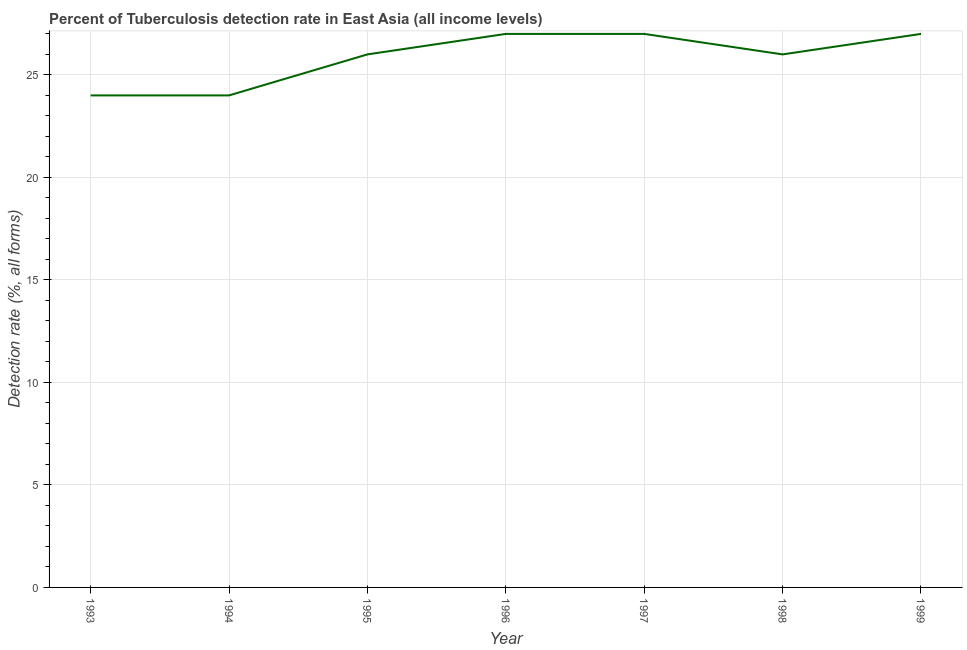What is the detection rate of tuberculosis in 1999?
Give a very brief answer. 27. Across all years, what is the maximum detection rate of tuberculosis?
Your answer should be very brief. 27. Across all years, what is the minimum detection rate of tuberculosis?
Your answer should be compact. 24. In which year was the detection rate of tuberculosis minimum?
Keep it short and to the point. 1993. What is the sum of the detection rate of tuberculosis?
Keep it short and to the point. 181. What is the difference between the detection rate of tuberculosis in 1998 and 1999?
Make the answer very short. -1. What is the average detection rate of tuberculosis per year?
Make the answer very short. 25.86. What is the median detection rate of tuberculosis?
Keep it short and to the point. 26. Do a majority of the years between 1999 and 1997 (inclusive) have detection rate of tuberculosis greater than 2 %?
Offer a very short reply. No. What is the ratio of the detection rate of tuberculosis in 1993 to that in 1997?
Your answer should be compact. 0.89. Is the difference between the detection rate of tuberculosis in 1993 and 1996 greater than the difference between any two years?
Provide a succinct answer. Yes. What is the difference between the highest and the second highest detection rate of tuberculosis?
Your response must be concise. 0. What is the difference between the highest and the lowest detection rate of tuberculosis?
Your response must be concise. 3. In how many years, is the detection rate of tuberculosis greater than the average detection rate of tuberculosis taken over all years?
Provide a short and direct response. 5. Does the detection rate of tuberculosis monotonically increase over the years?
Ensure brevity in your answer.  No. Are the values on the major ticks of Y-axis written in scientific E-notation?
Provide a short and direct response. No. Does the graph contain grids?
Make the answer very short. Yes. What is the title of the graph?
Ensure brevity in your answer.  Percent of Tuberculosis detection rate in East Asia (all income levels). What is the label or title of the X-axis?
Offer a terse response. Year. What is the label or title of the Y-axis?
Give a very brief answer. Detection rate (%, all forms). What is the Detection rate (%, all forms) of 1994?
Offer a very short reply. 24. What is the Detection rate (%, all forms) in 1996?
Offer a very short reply. 27. What is the Detection rate (%, all forms) in 1997?
Offer a very short reply. 27. What is the difference between the Detection rate (%, all forms) in 1993 and 1997?
Offer a very short reply. -3. What is the difference between the Detection rate (%, all forms) in 1993 and 1998?
Your answer should be compact. -2. What is the difference between the Detection rate (%, all forms) in 1994 and 1996?
Offer a very short reply. -3. What is the difference between the Detection rate (%, all forms) in 1994 and 1998?
Provide a short and direct response. -2. What is the difference between the Detection rate (%, all forms) in 1995 and 1997?
Provide a succinct answer. -1. What is the difference between the Detection rate (%, all forms) in 1995 and 1999?
Give a very brief answer. -1. What is the difference between the Detection rate (%, all forms) in 1996 and 1997?
Ensure brevity in your answer.  0. What is the difference between the Detection rate (%, all forms) in 1997 and 1998?
Your answer should be compact. 1. What is the ratio of the Detection rate (%, all forms) in 1993 to that in 1994?
Keep it short and to the point. 1. What is the ratio of the Detection rate (%, all forms) in 1993 to that in 1995?
Your answer should be compact. 0.92. What is the ratio of the Detection rate (%, all forms) in 1993 to that in 1996?
Provide a short and direct response. 0.89. What is the ratio of the Detection rate (%, all forms) in 1993 to that in 1997?
Provide a succinct answer. 0.89. What is the ratio of the Detection rate (%, all forms) in 1993 to that in 1998?
Provide a short and direct response. 0.92. What is the ratio of the Detection rate (%, all forms) in 1993 to that in 1999?
Offer a terse response. 0.89. What is the ratio of the Detection rate (%, all forms) in 1994 to that in 1995?
Your answer should be compact. 0.92. What is the ratio of the Detection rate (%, all forms) in 1994 to that in 1996?
Your response must be concise. 0.89. What is the ratio of the Detection rate (%, all forms) in 1994 to that in 1997?
Ensure brevity in your answer.  0.89. What is the ratio of the Detection rate (%, all forms) in 1994 to that in 1998?
Your response must be concise. 0.92. What is the ratio of the Detection rate (%, all forms) in 1994 to that in 1999?
Make the answer very short. 0.89. What is the ratio of the Detection rate (%, all forms) in 1995 to that in 1996?
Provide a succinct answer. 0.96. What is the ratio of the Detection rate (%, all forms) in 1996 to that in 1997?
Provide a short and direct response. 1. What is the ratio of the Detection rate (%, all forms) in 1996 to that in 1998?
Offer a terse response. 1.04. What is the ratio of the Detection rate (%, all forms) in 1997 to that in 1998?
Offer a very short reply. 1.04. What is the ratio of the Detection rate (%, all forms) in 1997 to that in 1999?
Provide a succinct answer. 1. 